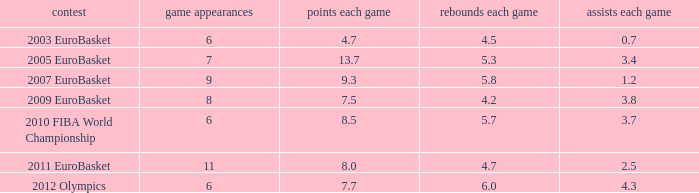How many games played have 4.7 as points per game? 6.0. 